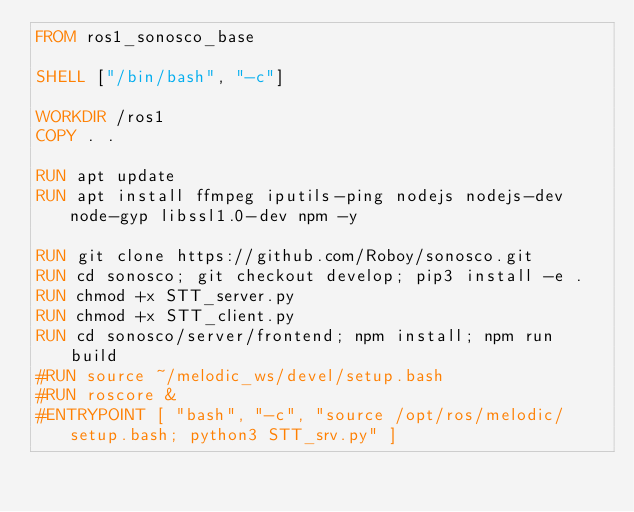Convert code to text. <code><loc_0><loc_0><loc_500><loc_500><_Dockerfile_>FROM ros1_sonosco_base

SHELL ["/bin/bash", "-c"]

WORKDIR /ros1
COPY . .

RUN apt update
RUN apt install ffmpeg iputils-ping nodejs nodejs-dev node-gyp libssl1.0-dev npm -y

RUN git clone https://github.com/Roboy/sonosco.git
RUN cd sonosco; git checkout develop; pip3 install -e .
RUN chmod +x STT_server.py
RUN chmod +x STT_client.py
RUN cd sonosco/server/frontend; npm install; npm run build
#RUN source ~/melodic_ws/devel/setup.bash
#RUN roscore &
#ENTRYPOINT [ "bash", "-c", "source /opt/ros/melodic/setup.bash; python3 STT_srv.py" ]
</code> 